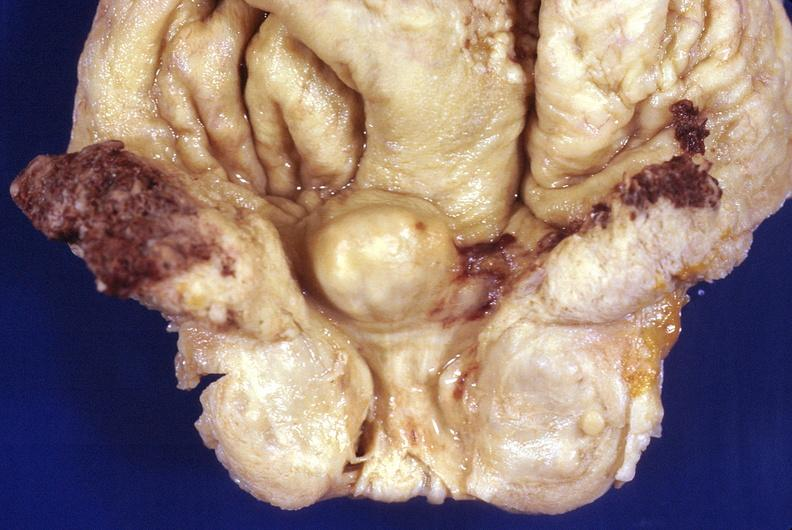does this image show prostatic hyperplasia?
Answer the question using a single word or phrase. Yes 